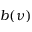Convert formula to latex. <formula><loc_0><loc_0><loc_500><loc_500>b ( \nu )</formula> 